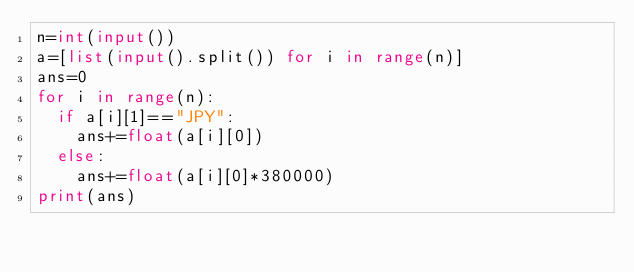Convert code to text. <code><loc_0><loc_0><loc_500><loc_500><_Python_>n=int(input())
a=[list(input().split()) for i in range(n)]
ans=0
for i in range(n):
  if a[i][1]=="JPY":
    ans+=float(a[i][0])
  else:
    ans+=float(a[i][0]*380000)
print(ans)</code> 